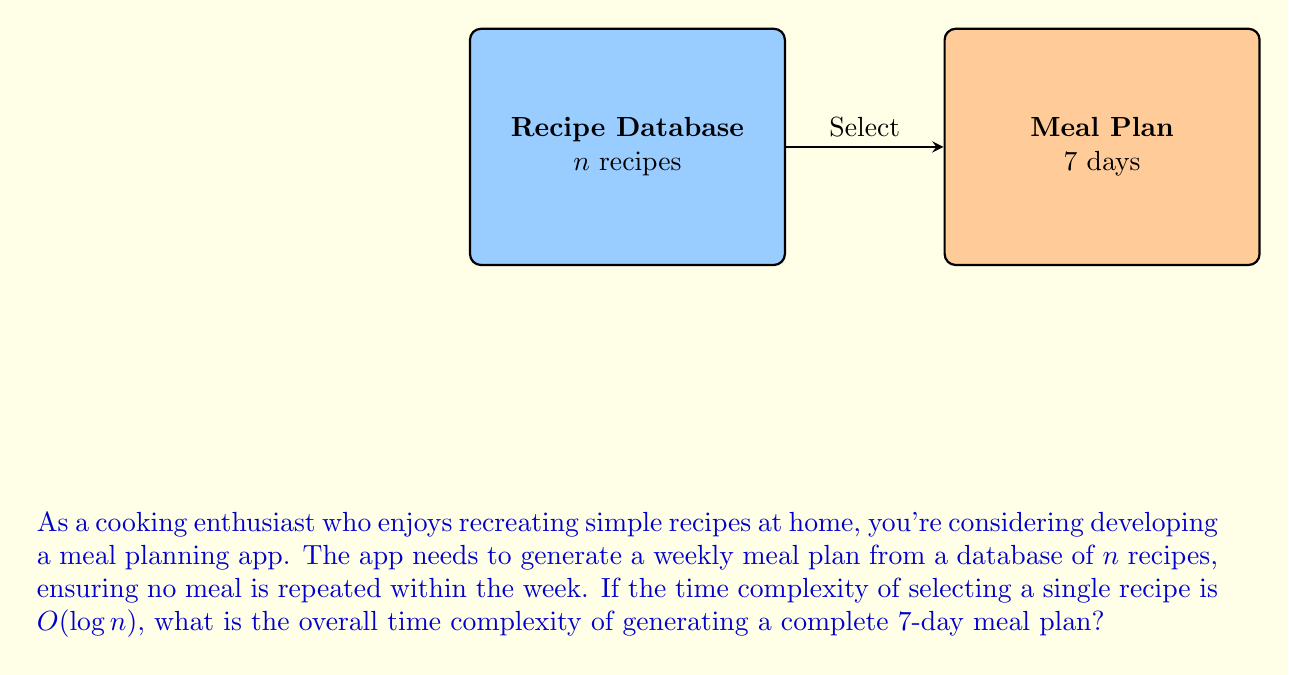Provide a solution to this math problem. Let's break this down step-by-step:

1) We need to select 7 unique meals for the week.

2) For each meal selection:
   - The time complexity is $O(\log n)$ to select a recipe from the database.
   - We also need to ensure the recipe hasn't been used before in the week. In the worst case, this could require checking all previously selected meals.

3) Let's consider the selections one by one:
   - 1st selection: $O(\log n)$
   - 2nd selection: $O(\log n + 1)$ (check 1 previous meal)
   - 3rd selection: $O(\log n + 2)$ (check 2 previous meals)
   ...
   - 7th selection: $O(\log n + 6)$ (check 6 previous meals)

4) The total time complexity is the sum of these:
   $$O(\log n) + O(\log n + 1) + O(\log n + 2) + ... + O(\log n + 6)$$

5) This simplifies to:
   $$O(7\log n + (0 + 1 + 2 + 3 + 4 + 5 + 6))$$

6) The sum of 0 to 6 is 21, so we have:
   $$O(7\log n + 21)$$

7) The constant 21 is insignificant for big O notation, so we can remove it:
   $$O(7\log n)$$

8) The constant factor 7 is also typically omitted in big O notation, leaving us with:
   $$O(\log n)$$
Answer: $O(\log n)$ 